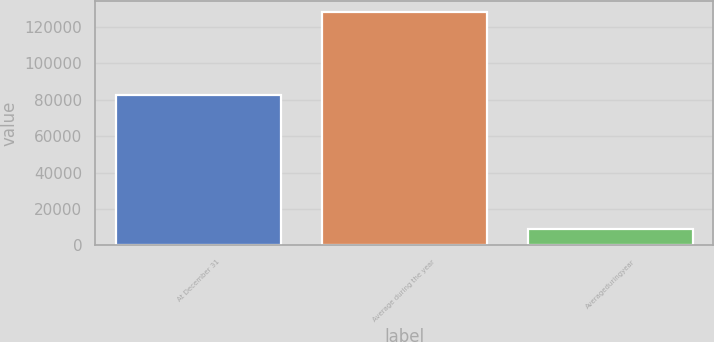<chart> <loc_0><loc_0><loc_500><loc_500><bar_chart><fcel>At December 31<fcel>Average during the year<fcel>Averageduringyear<nl><fcel>82478<fcel>128053<fcel>8969<nl></chart> 